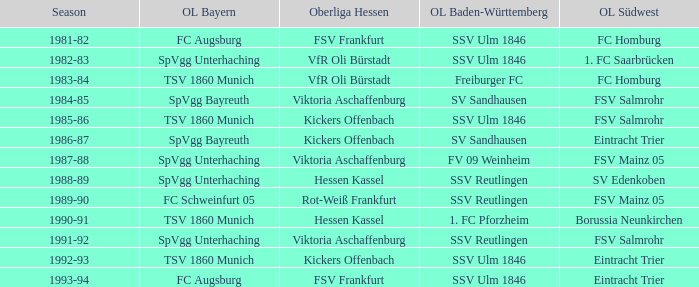Could you parse the entire table? {'header': ['Season', 'OL Bayern', 'Oberliga Hessen', 'OL Baden-Württemberg', 'OL Südwest'], 'rows': [['1981-82', 'FC Augsburg', 'FSV Frankfurt', 'SSV Ulm 1846', 'FC Homburg'], ['1982-83', 'SpVgg Unterhaching', 'VfR Oli Bürstadt', 'SSV Ulm 1846', '1. FC Saarbrücken'], ['1983-84', 'TSV 1860 Munich', 'VfR Oli Bürstadt', 'Freiburger FC', 'FC Homburg'], ['1984-85', 'SpVgg Bayreuth', 'Viktoria Aschaffenburg', 'SV Sandhausen', 'FSV Salmrohr'], ['1985-86', 'TSV 1860 Munich', 'Kickers Offenbach', 'SSV Ulm 1846', 'FSV Salmrohr'], ['1986-87', 'SpVgg Bayreuth', 'Kickers Offenbach', 'SV Sandhausen', 'Eintracht Trier'], ['1987-88', 'SpVgg Unterhaching', 'Viktoria Aschaffenburg', 'FV 09 Weinheim', 'FSV Mainz 05'], ['1988-89', 'SpVgg Unterhaching', 'Hessen Kassel', 'SSV Reutlingen', 'SV Edenkoben'], ['1989-90', 'FC Schweinfurt 05', 'Rot-Weiß Frankfurt', 'SSV Reutlingen', 'FSV Mainz 05'], ['1990-91', 'TSV 1860 Munich', 'Hessen Kassel', '1. FC Pforzheim', 'Borussia Neunkirchen'], ['1991-92', 'SpVgg Unterhaching', 'Viktoria Aschaffenburg', 'SSV Reutlingen', 'FSV Salmrohr'], ['1992-93', 'TSV 1860 Munich', 'Kickers Offenbach', 'SSV Ulm 1846', 'Eintracht Trier'], ['1993-94', 'FC Augsburg', 'FSV Frankfurt', 'SSV Ulm 1846', 'Eintracht Trier']]} Which Oberliga Südwest has an Oberliga Bayern of fc schweinfurt 05? FSV Mainz 05. 